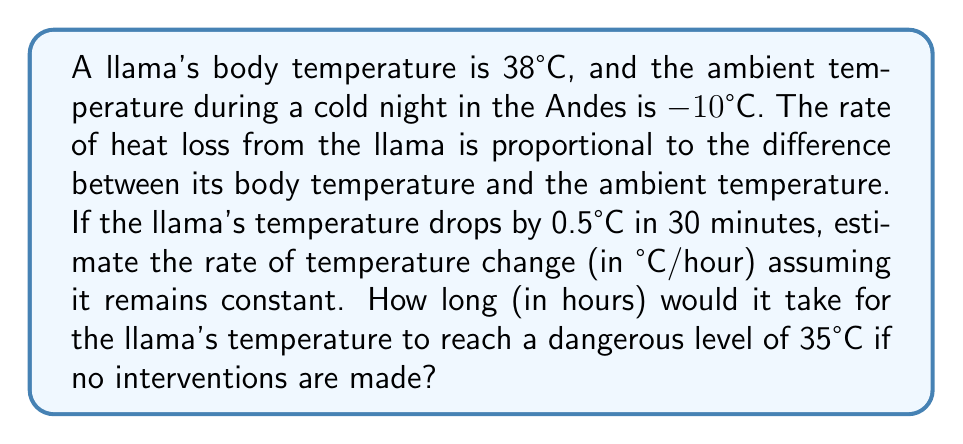Give your solution to this math problem. Let's approach this step-by-step:

1) First, we need to find the rate of temperature change.
   Initial temperature difference: $\Delta T_i = 38°C - (-10°C) = 48°C$
   Temperature drop in 30 minutes: $0.5°C$

2) Rate of temperature change:
   $$\text{Rate} = \frac{0.5°C}{0.5\text{ hour}} = 1°C/\text{hour}$$

3) Now, we need to find how long it would take to reach 35°C.
   Temperature drop needed: $38°C - 35°C = 3°C$

4) Time to reach 35°C:
   $$\text{Time} = \frac{\text{Temperature drop}}{\text{Rate of change}} = \frac{3°C}{1°C/\text{hour}} = 3\text{ hours}$$

5) We can verify this using the heat equation:
   $$\frac{dT}{dt} = -k(T - T_a)$$
   where $T$ is the llama's temperature, $T_a$ is the ambient temperature, and $k$ is a constant.

6) We can find $k$ using the initial conditions:
   $$1°C/\text{hour} = -k(38°C - (-10°C))$$
   $$k = \frac{1}{48} \approx 0.0208\text{ hour}^{-1}$$

7) The solution to this differential equation is:
   $$T(t) = T_a + (T_0 - T_a)e^{-kt}$$
   where $T_0$ is the initial temperature.

8) We can confirm our answer by solving:
   $$35 = -10 + (38 - (-10))e^{-0.0208t}$$
   $$45 = 48e^{-0.0208t}$$
   $$\ln(\frac{45}{48}) = -0.0208t$$
   $$t \approx 3\text{ hours}$$

This confirms our initial calculation.
Answer: 3 hours 